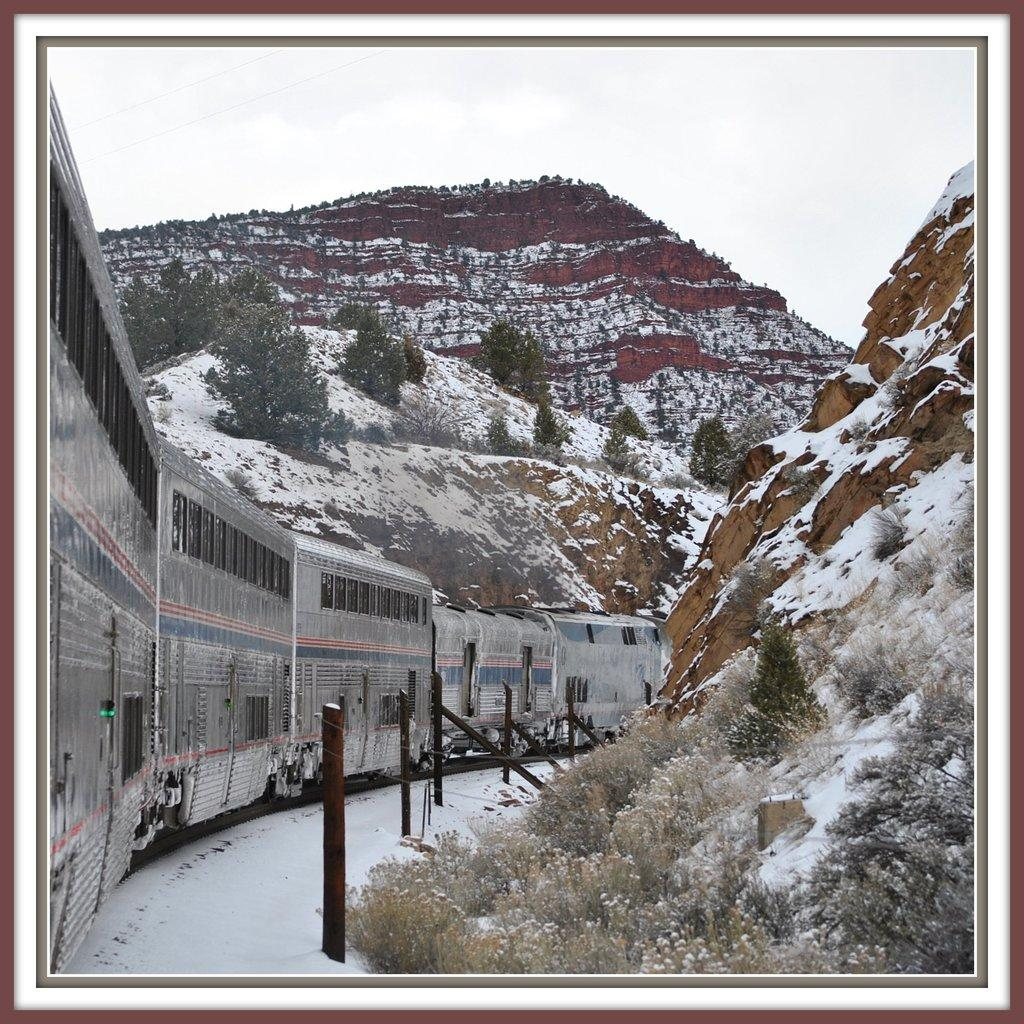What is the main subject of the image? The main subject of the image is a train. What other natural elements can be seen in the image? There are trees and mountains in the image. What is the condition of the mountains? The mountains are covered with snow. What is visible at the top of the image? The sky is visible at the top of the image. How is the image presented? The image has borders. How does the ink on the train move in the image? There is no ink present on the train in the image; it is a physical train, not a drawing or illustration. 